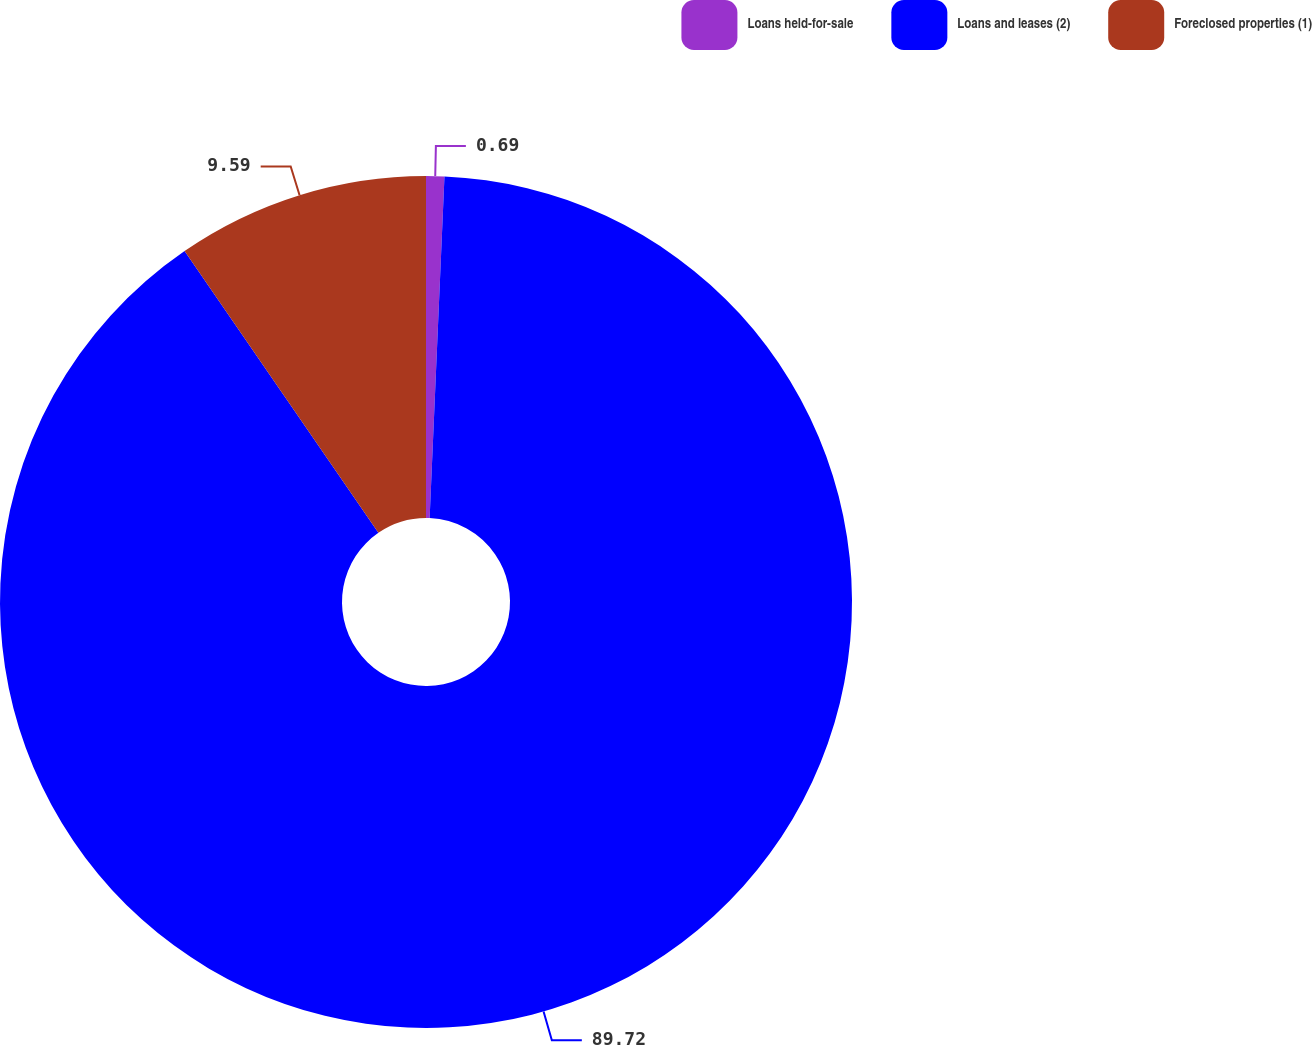<chart> <loc_0><loc_0><loc_500><loc_500><pie_chart><fcel>Loans held-for-sale<fcel>Loans and leases (2)<fcel>Foreclosed properties (1)<nl><fcel>0.69%<fcel>89.72%<fcel>9.59%<nl></chart> 